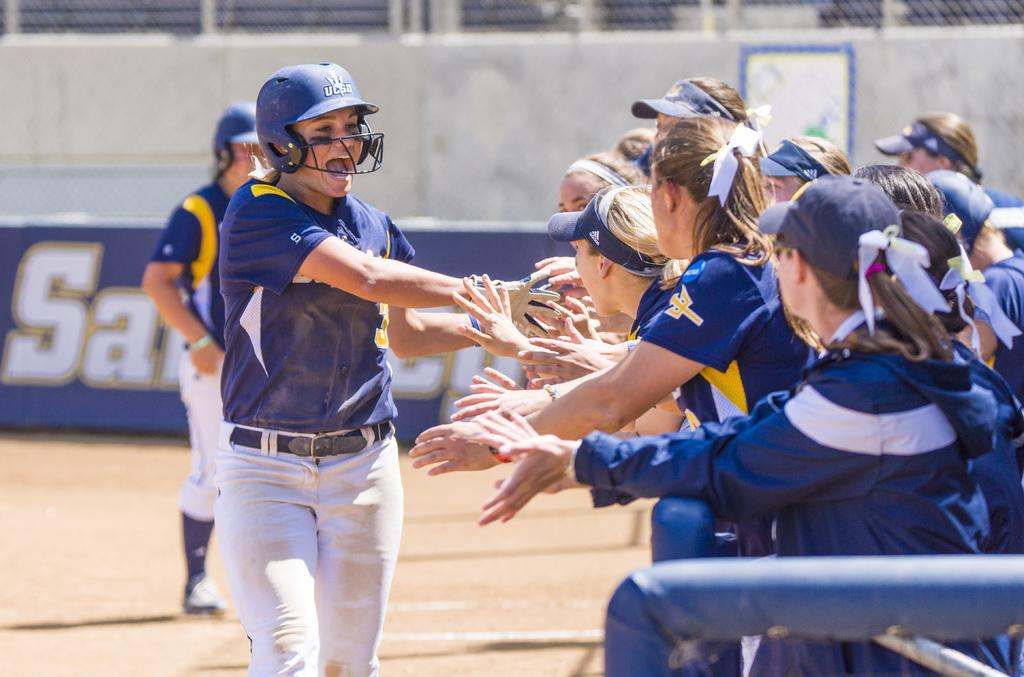What is happening in the foreground of the image? There are persons on the ground in the image. What can be seen in the background of the image? There is a hoarding and a wall in the background of the image. How many wilderness areas are visible in the image? There is no wilderness area present in the image; it features persons on the ground and a hoarding and wall in the background. What is stopping the persons from moving in the image? There is no indication in the image that the persons are being stopped from moving; they are simply standing or sitting on the ground. 